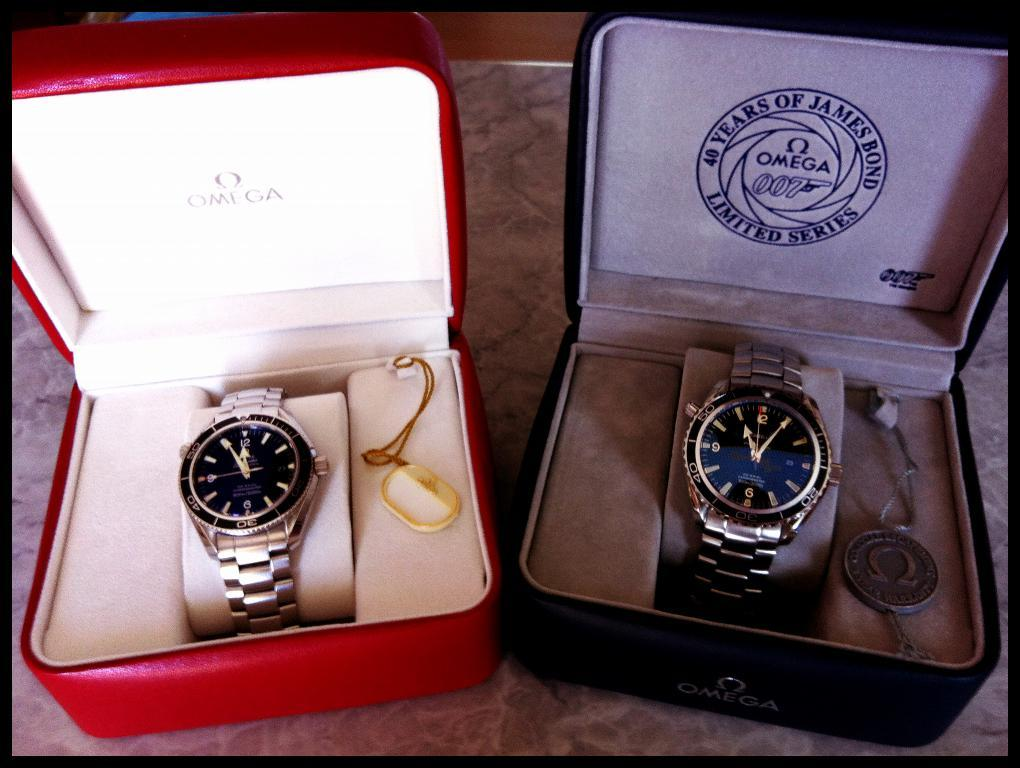<image>
Render a clear and concise summary of the photo. Two clocks next to one another with one that has a box which says "40 years of James Bond". 